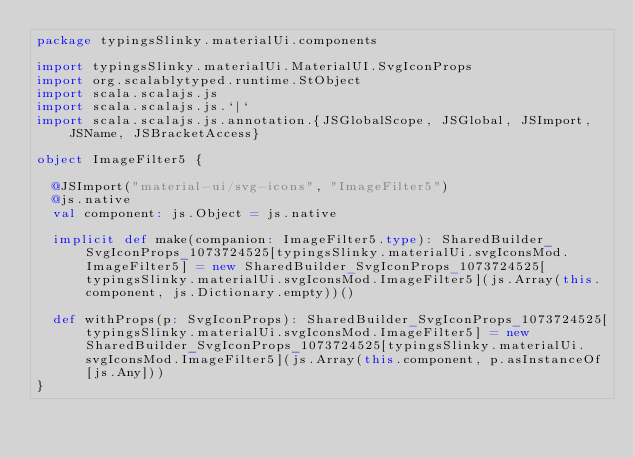<code> <loc_0><loc_0><loc_500><loc_500><_Scala_>package typingsSlinky.materialUi.components

import typingsSlinky.materialUi.MaterialUI.SvgIconProps
import org.scalablytyped.runtime.StObject
import scala.scalajs.js
import scala.scalajs.js.`|`
import scala.scalajs.js.annotation.{JSGlobalScope, JSGlobal, JSImport, JSName, JSBracketAccess}

object ImageFilter5 {
  
  @JSImport("material-ui/svg-icons", "ImageFilter5")
  @js.native
  val component: js.Object = js.native
  
  implicit def make(companion: ImageFilter5.type): SharedBuilder_SvgIconProps_1073724525[typingsSlinky.materialUi.svgIconsMod.ImageFilter5] = new SharedBuilder_SvgIconProps_1073724525[typingsSlinky.materialUi.svgIconsMod.ImageFilter5](js.Array(this.component, js.Dictionary.empty))()
  
  def withProps(p: SvgIconProps): SharedBuilder_SvgIconProps_1073724525[typingsSlinky.materialUi.svgIconsMod.ImageFilter5] = new SharedBuilder_SvgIconProps_1073724525[typingsSlinky.materialUi.svgIconsMod.ImageFilter5](js.Array(this.component, p.asInstanceOf[js.Any]))
}
</code> 